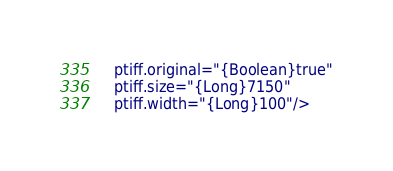<code> <loc_0><loc_0><loc_500><loc_500><_XML_>    ptiff.original="{Boolean}true"
    ptiff.size="{Long}7150"
    ptiff.width="{Long}100"/>
</code> 